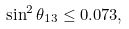<formula> <loc_0><loc_0><loc_500><loc_500>\sin ^ { 2 } \theta _ { 1 3 } \leq 0 . 0 7 3 ,</formula> 